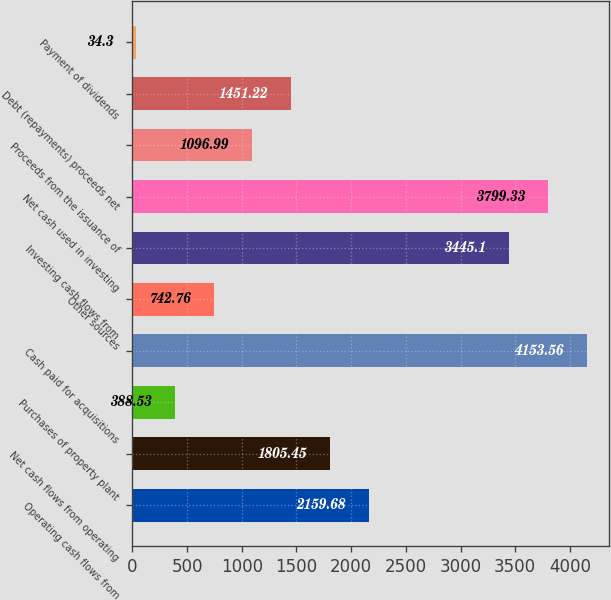Convert chart. <chart><loc_0><loc_0><loc_500><loc_500><bar_chart><fcel>Operating cash flows from<fcel>Net cash flows from operating<fcel>Purchases of property plant<fcel>Cash paid for acquisitions<fcel>Other sources<fcel>Investing cash flows from<fcel>Net cash used in investing<fcel>Proceeds from the issuance of<fcel>Debt (repayments) proceeds net<fcel>Payment of dividends<nl><fcel>2159.68<fcel>1805.45<fcel>388.53<fcel>4153.56<fcel>742.76<fcel>3445.1<fcel>3799.33<fcel>1096.99<fcel>1451.22<fcel>34.3<nl></chart> 